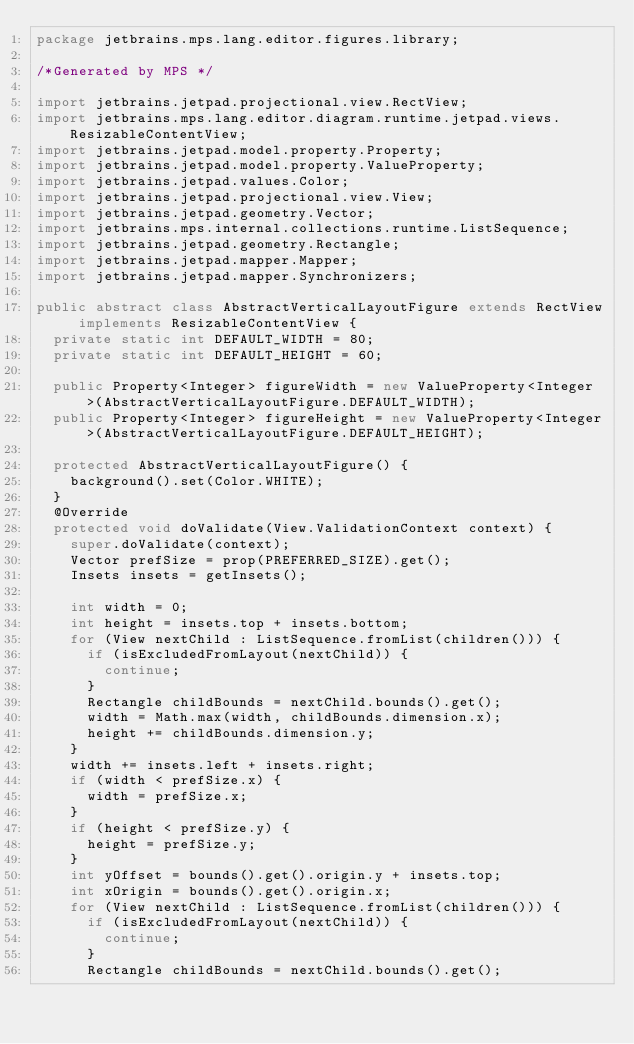<code> <loc_0><loc_0><loc_500><loc_500><_Java_>package jetbrains.mps.lang.editor.figures.library;

/*Generated by MPS */

import jetbrains.jetpad.projectional.view.RectView;
import jetbrains.mps.lang.editor.diagram.runtime.jetpad.views.ResizableContentView;
import jetbrains.jetpad.model.property.Property;
import jetbrains.jetpad.model.property.ValueProperty;
import jetbrains.jetpad.values.Color;
import jetbrains.jetpad.projectional.view.View;
import jetbrains.jetpad.geometry.Vector;
import jetbrains.mps.internal.collections.runtime.ListSequence;
import jetbrains.jetpad.geometry.Rectangle;
import jetbrains.jetpad.mapper.Mapper;
import jetbrains.jetpad.mapper.Synchronizers;

public abstract class AbstractVerticalLayoutFigure extends RectView implements ResizableContentView {
  private static int DEFAULT_WIDTH = 80;
  private static int DEFAULT_HEIGHT = 60;

  public Property<Integer> figureWidth = new ValueProperty<Integer>(AbstractVerticalLayoutFigure.DEFAULT_WIDTH);
  public Property<Integer> figureHeight = new ValueProperty<Integer>(AbstractVerticalLayoutFigure.DEFAULT_HEIGHT);

  protected AbstractVerticalLayoutFigure() {
    background().set(Color.WHITE);
  }
  @Override
  protected void doValidate(View.ValidationContext context) {
    super.doValidate(context);
    Vector prefSize = prop(PREFERRED_SIZE).get();
    Insets insets = getInsets();

    int width = 0;
    int height = insets.top + insets.bottom;
    for (View nextChild : ListSequence.fromList(children())) {
      if (isExcludedFromLayout(nextChild)) {
        continue;
      }
      Rectangle childBounds = nextChild.bounds().get();
      width = Math.max(width, childBounds.dimension.x);
      height += childBounds.dimension.y;
    }
    width += insets.left + insets.right;
    if (width < prefSize.x) {
      width = prefSize.x;
    }
    if (height < prefSize.y) {
      height = prefSize.y;
    }
    int yOffset = bounds().get().origin.y + insets.top;
    int xOrigin = bounds().get().origin.x;
    for (View nextChild : ListSequence.fromList(children())) {
      if (isExcludedFromLayout(nextChild)) {
        continue;
      }
      Rectangle childBounds = nextChild.bounds().get();</code> 